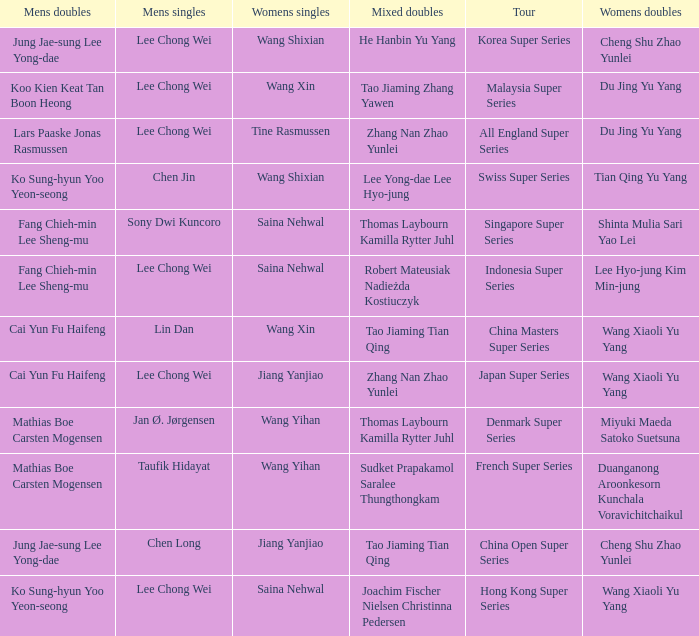Who is the mixed doubled on the tour korea super series? He Hanbin Yu Yang. Parse the table in full. {'header': ['Mens doubles', 'Mens singles', 'Womens singles', 'Mixed doubles', 'Tour', 'Womens doubles'], 'rows': [['Jung Jae-sung Lee Yong-dae', 'Lee Chong Wei', 'Wang Shixian', 'He Hanbin Yu Yang', 'Korea Super Series', 'Cheng Shu Zhao Yunlei'], ['Koo Kien Keat Tan Boon Heong', 'Lee Chong Wei', 'Wang Xin', 'Tao Jiaming Zhang Yawen', 'Malaysia Super Series', 'Du Jing Yu Yang'], ['Lars Paaske Jonas Rasmussen', 'Lee Chong Wei', 'Tine Rasmussen', 'Zhang Nan Zhao Yunlei', 'All England Super Series', 'Du Jing Yu Yang'], ['Ko Sung-hyun Yoo Yeon-seong', 'Chen Jin', 'Wang Shixian', 'Lee Yong-dae Lee Hyo-jung', 'Swiss Super Series', 'Tian Qing Yu Yang'], ['Fang Chieh-min Lee Sheng-mu', 'Sony Dwi Kuncoro', 'Saina Nehwal', 'Thomas Laybourn Kamilla Rytter Juhl', 'Singapore Super Series', 'Shinta Mulia Sari Yao Lei'], ['Fang Chieh-min Lee Sheng-mu', 'Lee Chong Wei', 'Saina Nehwal', 'Robert Mateusiak Nadieżda Kostiuczyk', 'Indonesia Super Series', 'Lee Hyo-jung Kim Min-jung'], ['Cai Yun Fu Haifeng', 'Lin Dan', 'Wang Xin', 'Tao Jiaming Tian Qing', 'China Masters Super Series', 'Wang Xiaoli Yu Yang'], ['Cai Yun Fu Haifeng', 'Lee Chong Wei', 'Jiang Yanjiao', 'Zhang Nan Zhao Yunlei', 'Japan Super Series', 'Wang Xiaoli Yu Yang'], ['Mathias Boe Carsten Mogensen', 'Jan Ø. Jørgensen', 'Wang Yihan', 'Thomas Laybourn Kamilla Rytter Juhl', 'Denmark Super Series', 'Miyuki Maeda Satoko Suetsuna'], ['Mathias Boe Carsten Mogensen', 'Taufik Hidayat', 'Wang Yihan', 'Sudket Prapakamol Saralee Thungthongkam', 'French Super Series', 'Duanganong Aroonkesorn Kunchala Voravichitchaikul'], ['Jung Jae-sung Lee Yong-dae', 'Chen Long', 'Jiang Yanjiao', 'Tao Jiaming Tian Qing', 'China Open Super Series', 'Cheng Shu Zhao Yunlei'], ['Ko Sung-hyun Yoo Yeon-seong', 'Lee Chong Wei', 'Saina Nehwal', 'Joachim Fischer Nielsen Christinna Pedersen', 'Hong Kong Super Series', 'Wang Xiaoli Yu Yang']]} 